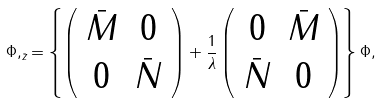Convert formula to latex. <formula><loc_0><loc_0><loc_500><loc_500>\Phi , _ { \bar { z } } = \left \{ \left ( \begin{array} { c c } \bar { M } & 0 \\ 0 & \bar { N } \end{array} \right ) + \frac { 1 } { \lambda } \left ( \begin{array} { c c } 0 & \bar { M } \\ \bar { N } & 0 \end{array} \right ) \right \} \Phi ,</formula> 